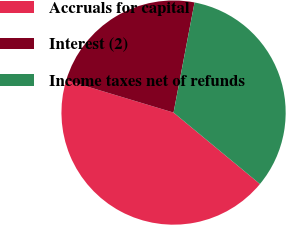Convert chart to OTSL. <chart><loc_0><loc_0><loc_500><loc_500><pie_chart><fcel>Accruals for capital<fcel>Interest (2)<fcel>Income taxes net of refunds<nl><fcel>43.66%<fcel>23.34%<fcel>33.0%<nl></chart> 